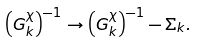<formula> <loc_0><loc_0><loc_500><loc_500>\left ( G ^ { \chi } _ { k } \right ) ^ { - 1 } \rightarrow \left ( G ^ { \chi } _ { k } \right ) ^ { - 1 } - \Sigma _ { k } .</formula> 